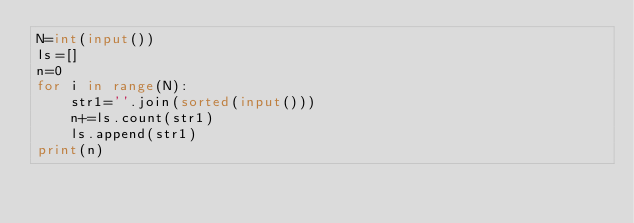Convert code to text. <code><loc_0><loc_0><loc_500><loc_500><_Python_>N=int(input())
ls=[]
n=0
for i in range(N):
    str1=''.join(sorted(input()))
    n+=ls.count(str1)
    ls.append(str1)
print(n)        
</code> 